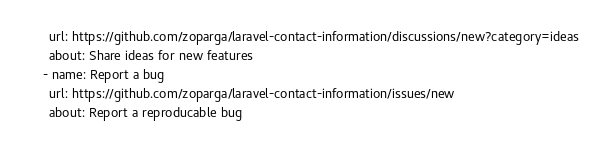Convert code to text. <code><loc_0><loc_0><loc_500><loc_500><_YAML_>      url: https://github.com/zoparga/laravel-contact-information/discussions/new?category=ideas
      about: Share ideas for new features
    - name: Report a bug
      url: https://github.com/zoparga/laravel-contact-information/issues/new
      about: Report a reproducable bug
</code> 